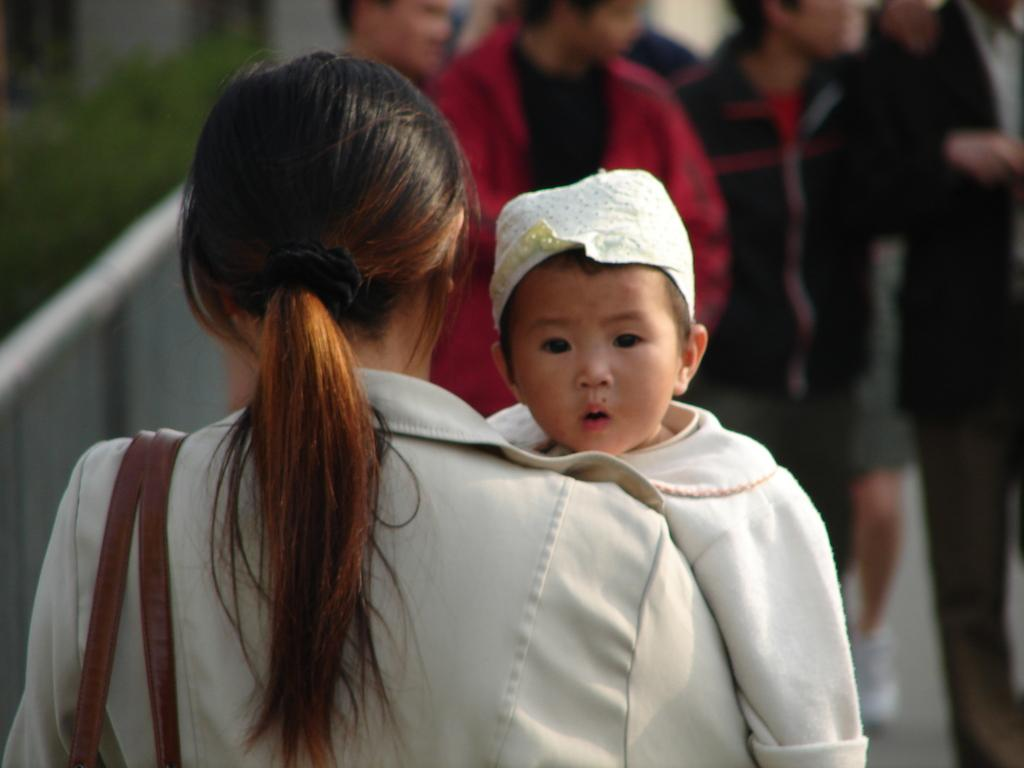Who is the main subject in the image? There is a lady in the image. What is the lady wearing? The lady is wearing a bag. What is the lady doing in the image? The lady is holding a kid. Are there any other people in the image? Yes, there are other people in front of the lady. How many cobwebs can be seen in the image? There are no cobwebs present in the image. What level of experience does the lady have as a beginner in the image? The image does not provide any information about the lady's experience level or whether she is a beginner at anything. 